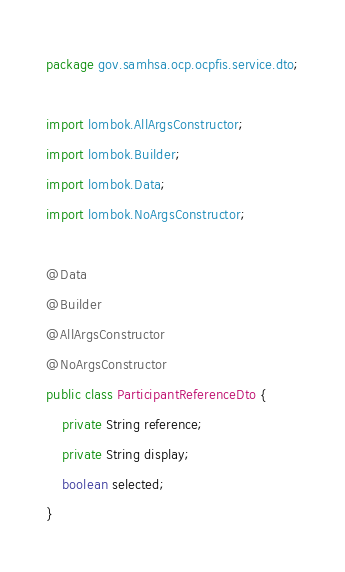Convert code to text. <code><loc_0><loc_0><loc_500><loc_500><_Java_>package gov.samhsa.ocp.ocpfis.service.dto;

import lombok.AllArgsConstructor;
import lombok.Builder;
import lombok.Data;
import lombok.NoArgsConstructor;

@Data
@Builder
@AllArgsConstructor
@NoArgsConstructor
public class ParticipantReferenceDto {
    private String reference;
    private String display;
    boolean selected;
}
</code> 